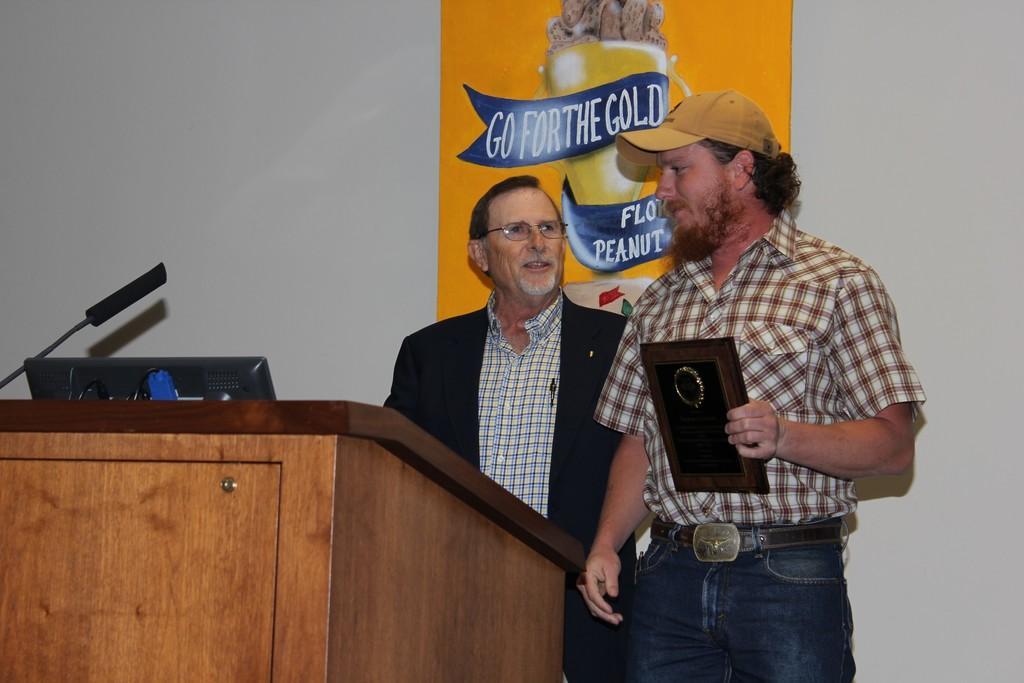How would you summarize this image in a sentence or two? In this image I can see two people are standing in front of the podium. I can see a mic, laptop on it and one person is holding something. Back I can see the orange board is attached to the white color wall. 